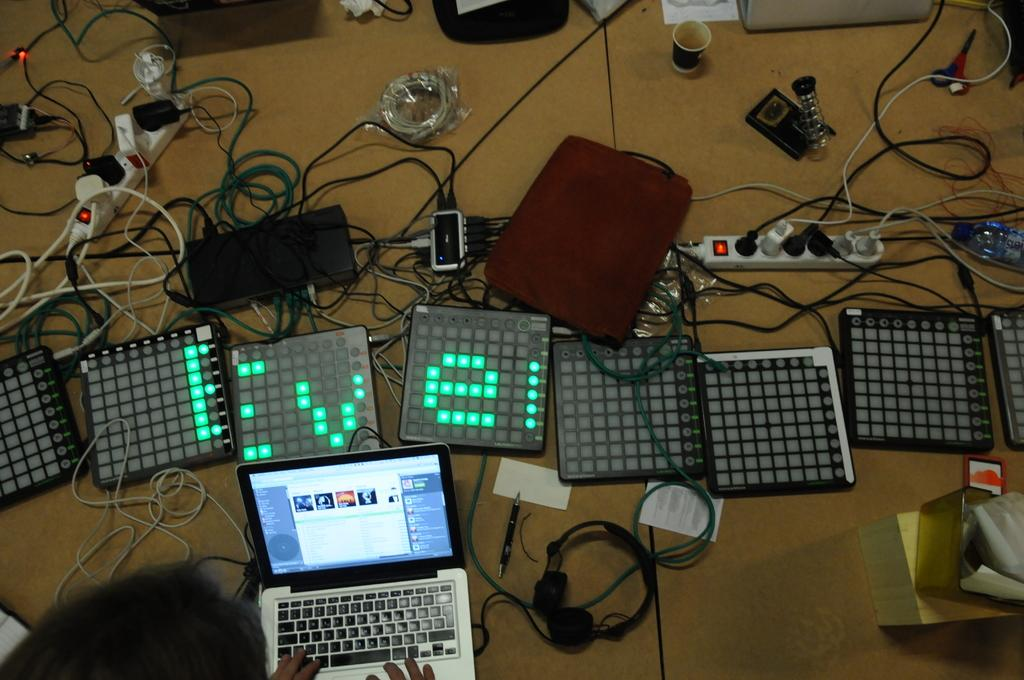<image>
Write a terse but informative summary of the picture. Several linked dot matrix displays with the letters "Eve" displayed across them with an open laptop at teh bottom. 